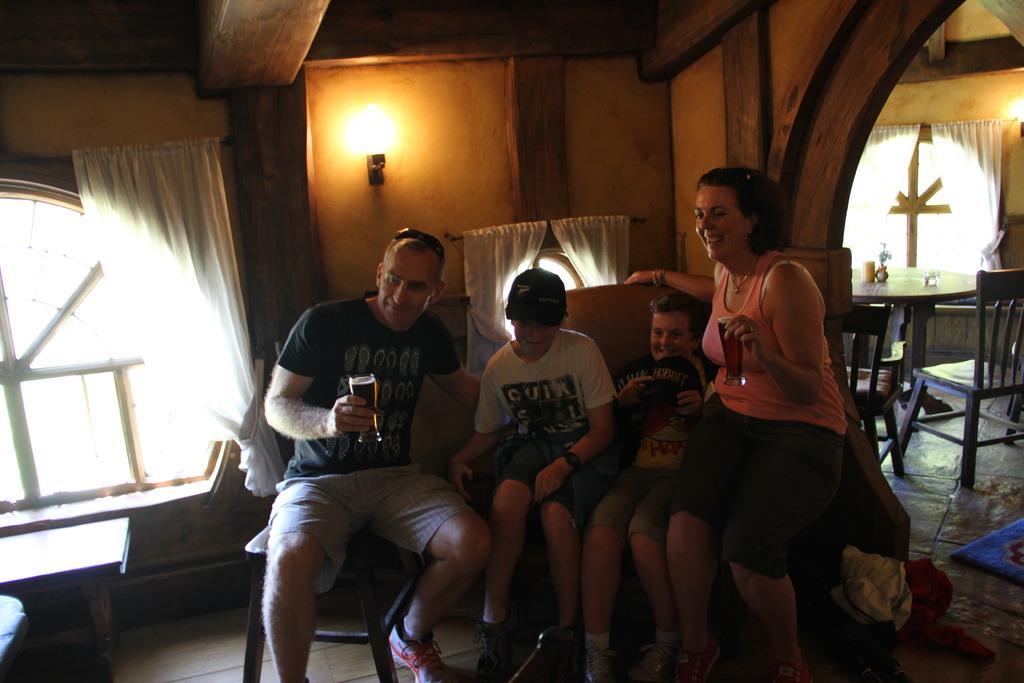Describe this image in one or two sentences. This is the picture inside the room. There are four people in the image, there are sitting and smiling. At the back there is a light and at the left there is a window and at the right there is a table and chairs and at the bottom there is a mat. 